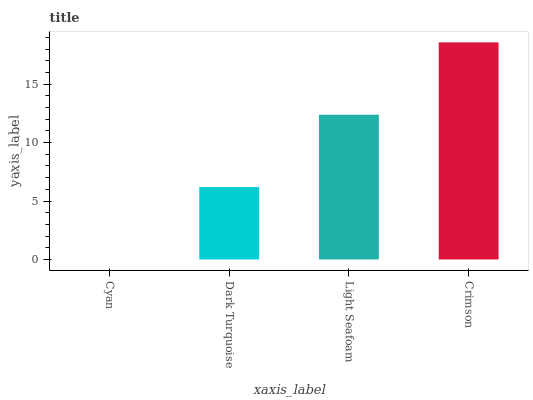Is Dark Turquoise the minimum?
Answer yes or no. No. Is Dark Turquoise the maximum?
Answer yes or no. No. Is Dark Turquoise greater than Cyan?
Answer yes or no. Yes. Is Cyan less than Dark Turquoise?
Answer yes or no. Yes. Is Cyan greater than Dark Turquoise?
Answer yes or no. No. Is Dark Turquoise less than Cyan?
Answer yes or no. No. Is Light Seafoam the high median?
Answer yes or no. Yes. Is Dark Turquoise the low median?
Answer yes or no. Yes. Is Crimson the high median?
Answer yes or no. No. Is Light Seafoam the low median?
Answer yes or no. No. 